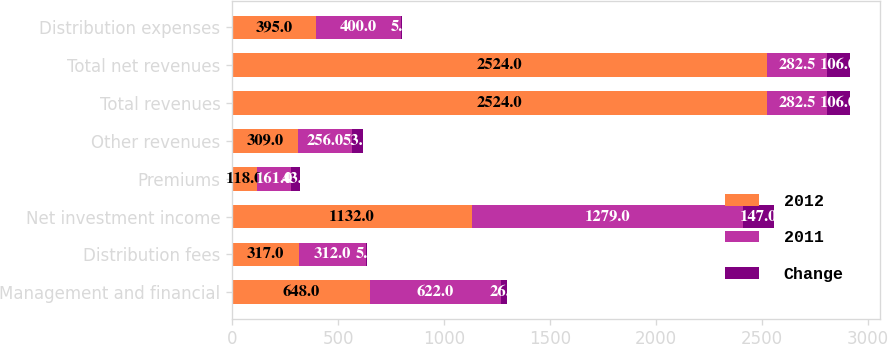Convert chart to OTSL. <chart><loc_0><loc_0><loc_500><loc_500><stacked_bar_chart><ecel><fcel>Management and financial<fcel>Distribution fees<fcel>Net investment income<fcel>Premiums<fcel>Other revenues<fcel>Total revenues<fcel>Total net revenues<fcel>Distribution expenses<nl><fcel>2012<fcel>648<fcel>317<fcel>1132<fcel>118<fcel>309<fcel>2524<fcel>2524<fcel>395<nl><fcel>2011<fcel>622<fcel>312<fcel>1279<fcel>161<fcel>256<fcel>282.5<fcel>282.5<fcel>400<nl><fcel>Change<fcel>26<fcel>5<fcel>147<fcel>43<fcel>53<fcel>106<fcel>106<fcel>5<nl></chart> 